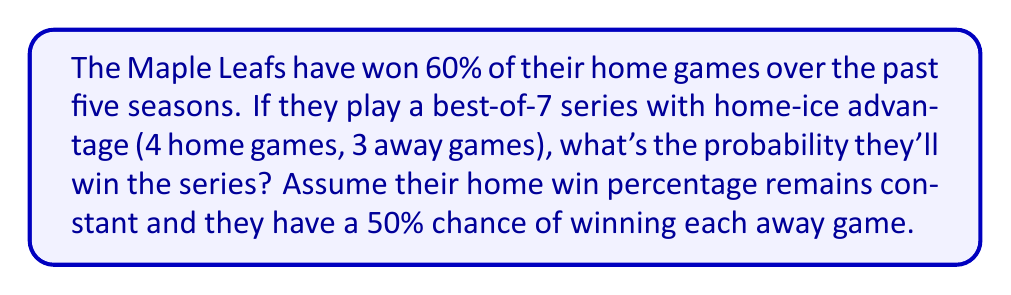What is the answer to this math problem? Let's approach this step-by-step:

1) First, we need to identify all the ways the Maple Leafs can win the series:
   - Win in 4 games (WWWW)
   - Win in 5 games (WWWLW, WWLWW, WLWWW, LWWWW)
   - Win in 6 games (WWWLLW, WWLWLW, WLWWLW, LWWWLW, WWLLWW, WLWLWW, LWWLWW)
   - Win in 7 games (WWWLLLW, WWLLWLW, WLWLWLW, LWWLWLW)

2) Now, let's calculate the probability of each outcome:
   - P(home win) = 0.6
   - P(away win) = 0.5
   - P(home loss) = 0.4
   - P(away loss) = 0.5

3) Probability of winning in 4 games:
   $P(4) = 0.6 \times 0.6 \times 0.5 \times 0.6 = 0.108$

4) Probability of winning in 5 games:
   $P(5) = 4 \times 0.6 \times 0.6 \times 0.5 \times 0.6 \times 0.5 = 0.216$

5) Probability of winning in 6 games:
   $P(6) = 4 \times 0.6 \times 0.6 \times 0.5 \times 0.4 \times 0.6 + 3 \times 0.6 \times 0.6 \times 0.5 \times 0.5 \times 0.6 = 0.1944$

6) Probability of winning in 7 games:
   $P(7) = 4 \times 0.6 \times 0.6 \times 0.5 \times 0.4 \times 0.5 \times 0.6 = 0.0864$

7) Total probability of winning the series:
   $P(total) = P(4) + P(5) + P(6) + P(7) = 0.108 + 0.216 + 0.1944 + 0.0864 = 0.6048$

Therefore, the probability of the Maple Leafs winning the series is approximately 0.6048 or 60.48%.
Answer: 0.6048 